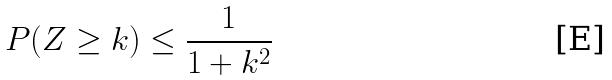<formula> <loc_0><loc_0><loc_500><loc_500>P ( Z \geq k ) \leq \frac { 1 } { 1 + k ^ { 2 } }</formula> 